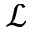Convert formula to latex. <formula><loc_0><loc_0><loc_500><loc_500>\mathcal { L }</formula> 